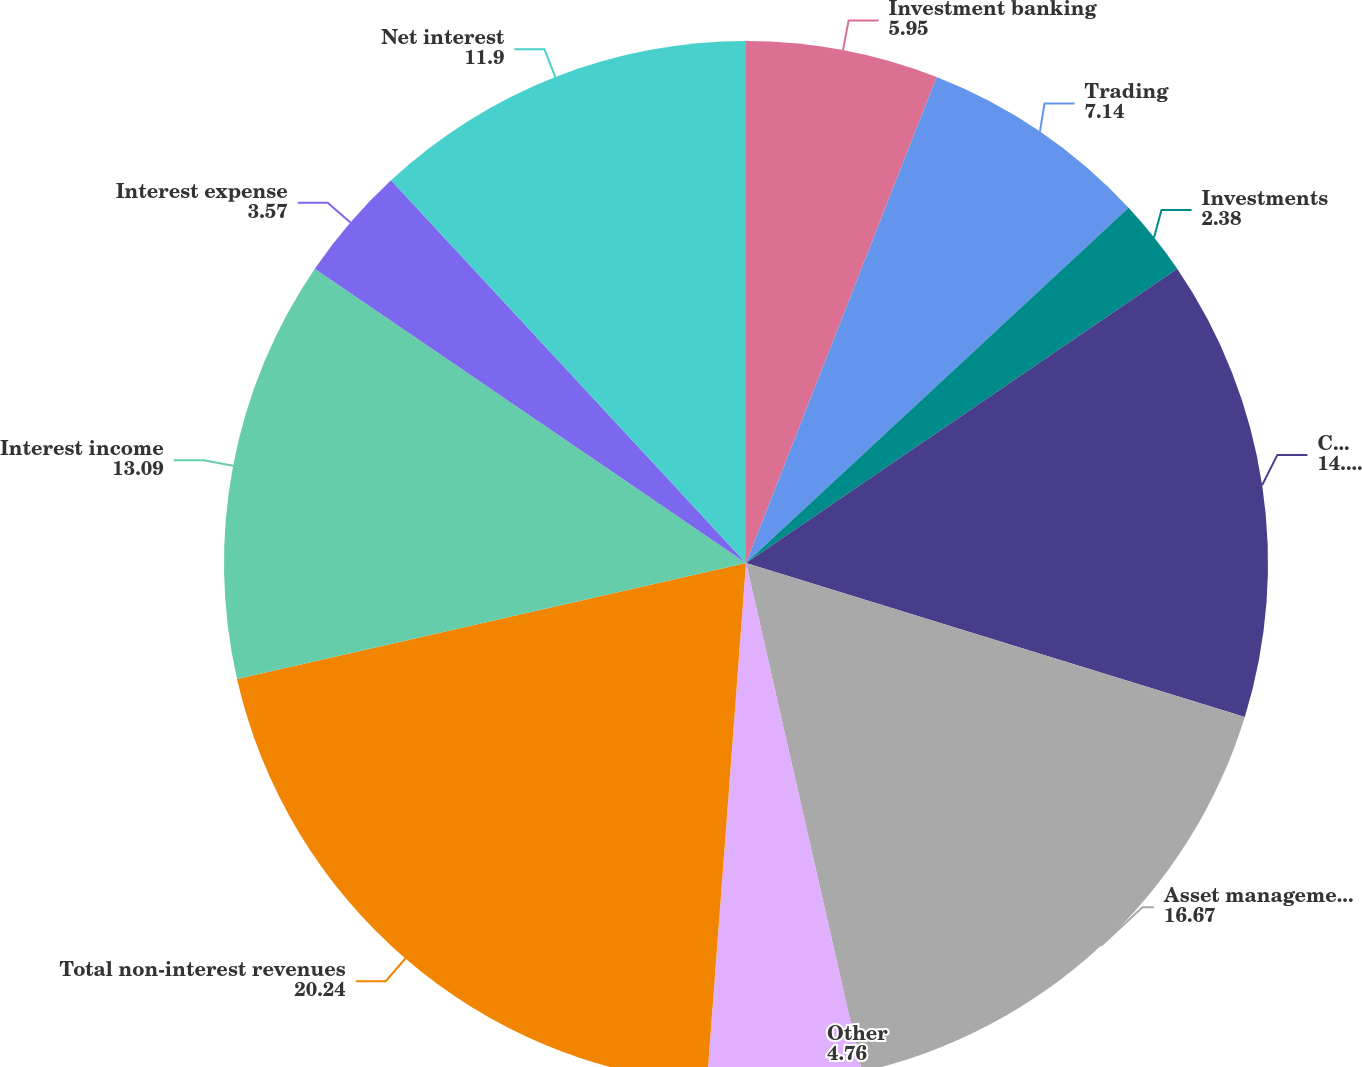Convert chart. <chart><loc_0><loc_0><loc_500><loc_500><pie_chart><fcel>Investment banking<fcel>Trading<fcel>Investments<fcel>Commissions and fees<fcel>Asset management distribution<fcel>Other<fcel>Total non-interest revenues<fcel>Interest income<fcel>Interest expense<fcel>Net interest<nl><fcel>5.95%<fcel>7.14%<fcel>2.38%<fcel>14.29%<fcel>16.67%<fcel>4.76%<fcel>20.24%<fcel>13.09%<fcel>3.57%<fcel>11.9%<nl></chart> 